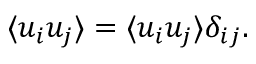<formula> <loc_0><loc_0><loc_500><loc_500>\langle u _ { i } u _ { j } \rangle = \langle u _ { i } u _ { j } \rangle \delta _ { i j } .</formula> 